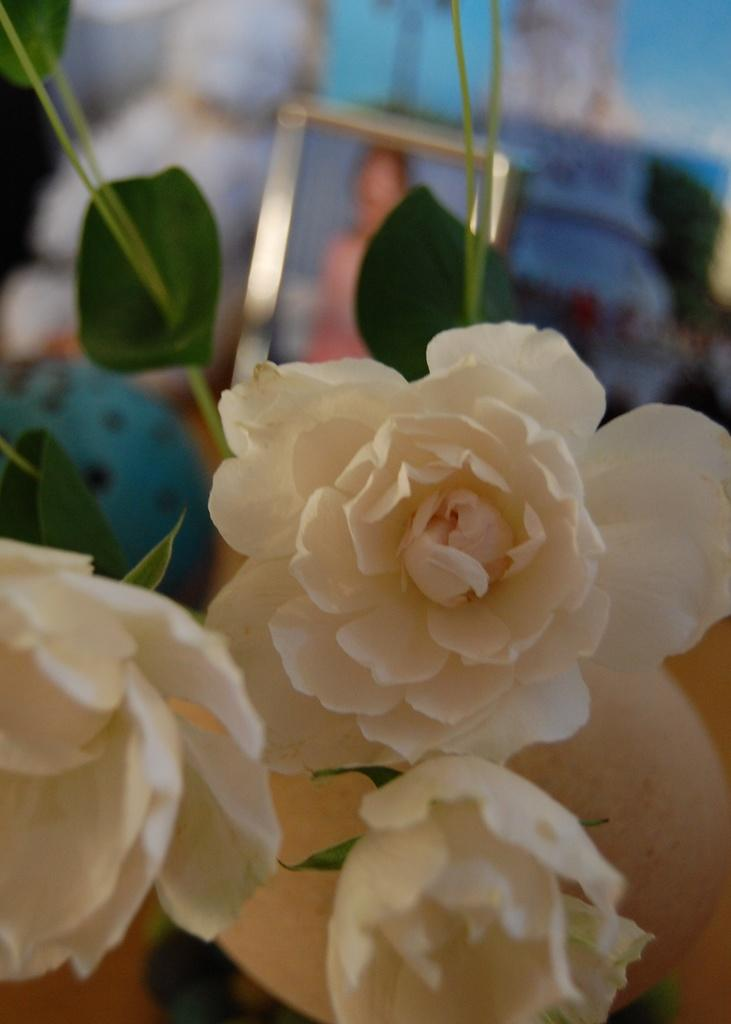What type of plants are in the image? There is a group of flowers in the image. What else can be seen in the image besides the flowers? There are leaves in the image. What is visible in the background of the image? There is a photo frame in the background of the image. What type of cakes are being served in the scene depicted in the image? There is no scene or cakes present in the image; it features a group of flowers and leaves with a photo frame in the background. 